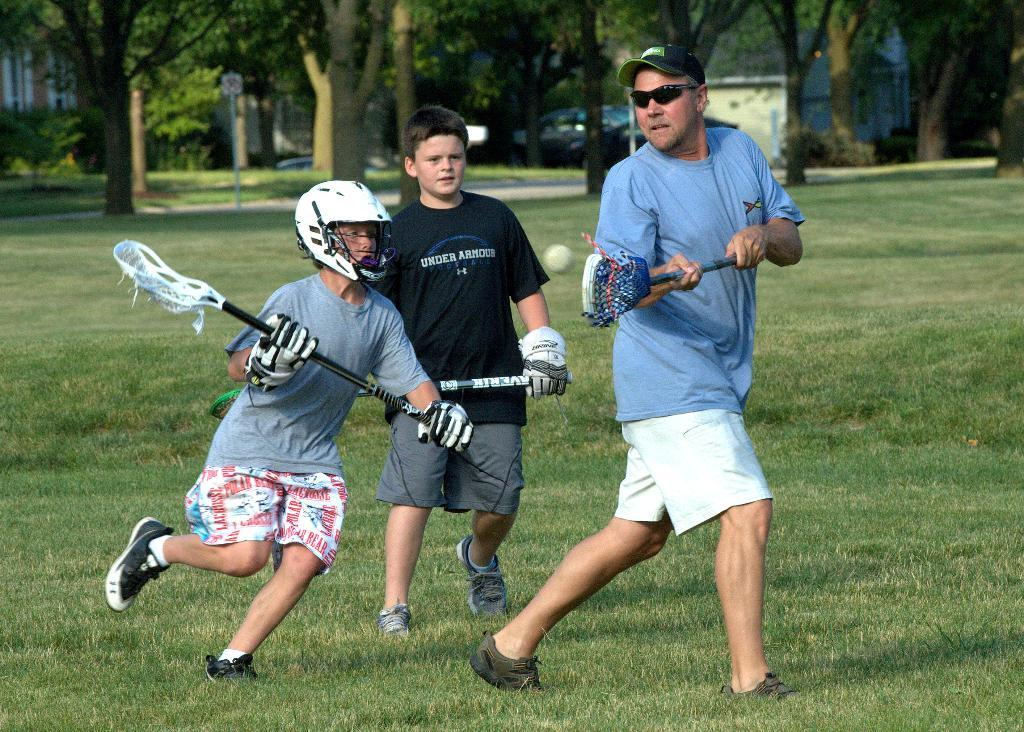How many people are in the image? There are three persons in the image. What are the persons doing in the image? The persons are standing on the ground and holding bats in their hands. What can be seen in the background of the image? There is a car, trees, a sign board, buildings, and a ball in the background of the image. What type of stitch is being used to sew the industry in the image? There is no mention of an industry or any sewing activity in the image. What type of wine is being served at the event in the image? There is no event or wine present in the image. 